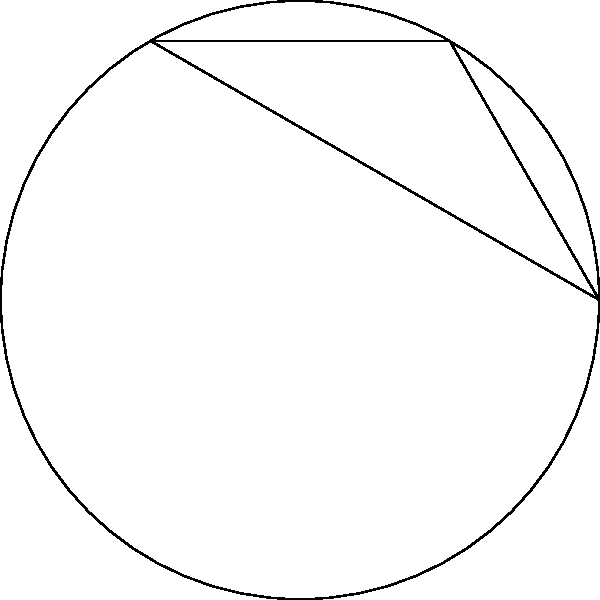In analyzing the curvature of a breaking ball's path, we model it using a circle. Three points A, B, and C are marked on the circle, forming an equilateral triangle. If tangent lines are drawn at these points, what is the area of the region bounded by these tangent lines? Let's approach this step-by-step:

1) First, we need to recognize that the triangle ABC is inscribed in the circle and is equilateral. This means that each of its angles is 60°.

2) The tangent lines at A, B, and C form a larger triangle outside the circle. Let's call the vertices of this larger triangle D, E, and F.

3) In a circle, the tangent line at any point is perpendicular to the radius drawn to that point. This means that triangles OAD, OBE, and OCF are all right-angled triangles.

4) In these right-angled triangles, one angle is 90° and another is 60° (half of the 120° angle between two radii). This means the third angle must be 30°.

5) Therefore, triangle DEF is equilateral, as all its angles are 30° + 30° + 30° = 90°.

6) The area of triangle DEF can be calculated if we know its side length. Let's find this:
   
   In triangle OAD: $\tan 60° = \frac{AD}{r}$
   
   $AD = r\tan 60° = r\sqrt{3}$

7) The side length of triangle DEF is twice this: $2r\sqrt{3}$

8) The area of an equilateral triangle with side $s$ is $\frac{\sqrt{3}}{4}s^2$

9) Therefore, the area of triangle DEF is:

   $Area = \frac{\sqrt{3}}{4}(2r\sqrt{3})^2 = \frac{\sqrt{3}}{4}(12r^2) = 3\sqrt{3}r^2$

This is the area bounded by the tangent lines.
Answer: $3\sqrt{3}r^2$ 